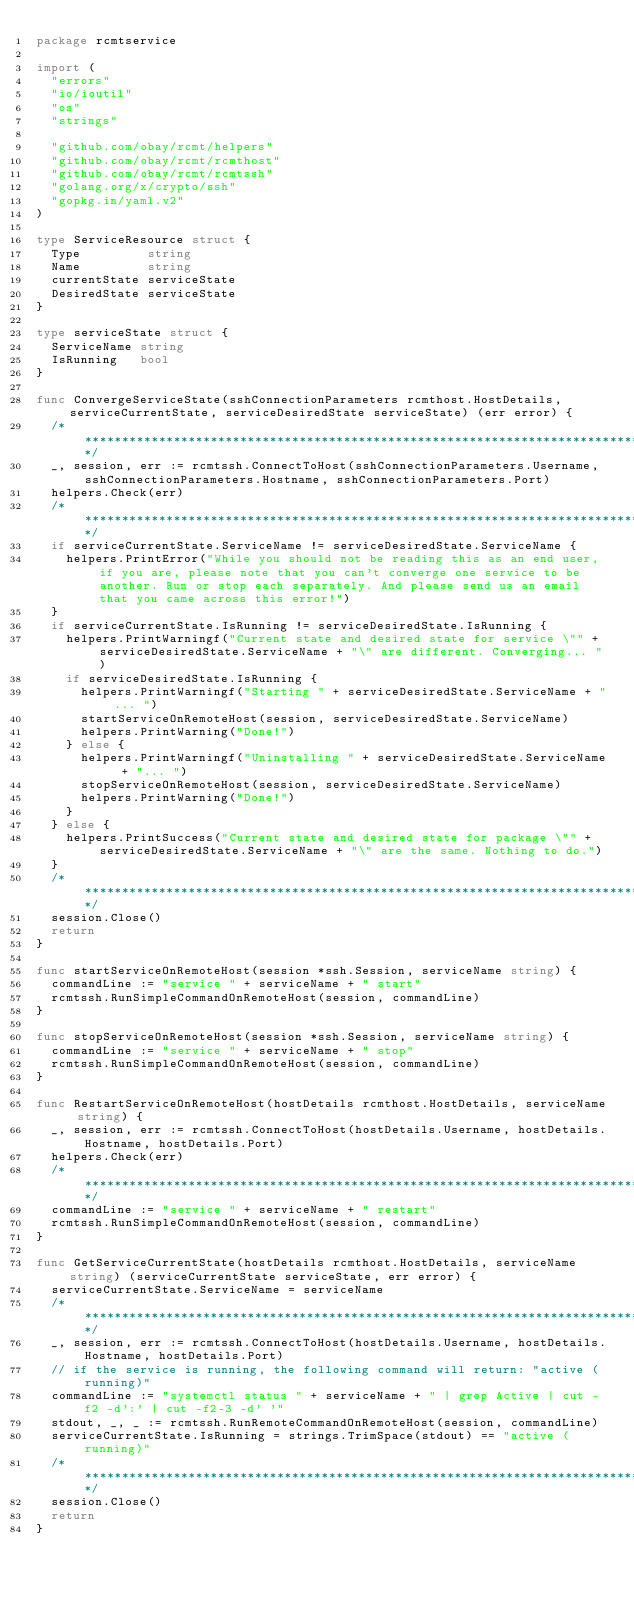<code> <loc_0><loc_0><loc_500><loc_500><_Go_>package rcmtservice

import (
	"errors"
	"io/ioutil"
	"os"
	"strings"

	"github.com/obay/rcmt/helpers"
	"github.com/obay/rcmt/rcmthost"
	"github.com/obay/rcmt/rcmtssh"
	"golang.org/x/crypto/ssh"
	"gopkg.in/yaml.v2"
)

type ServiceResource struct {
	Type         string
	Name         string
	currentState serviceState
	DesiredState serviceState
}

type serviceState struct {
	ServiceName string
	IsRunning   bool
}

func ConvergeServiceState(sshConnectionParameters rcmthost.HostDetails, serviceCurrentState, serviceDesiredState serviceState) (err error) {
	/*********************************************************************************************/
	_, session, err := rcmtssh.ConnectToHost(sshConnectionParameters.Username, sshConnectionParameters.Hostname, sshConnectionParameters.Port)
	helpers.Check(err)
	/*********************************************************************************************/
	if serviceCurrentState.ServiceName != serviceDesiredState.ServiceName {
		helpers.PrintError("While you should not be reading this as an end user, if you are, please note that you can't converge one service to be another. Run or stop each separately. And please send us an email that you came across this error!")
	}
	if serviceCurrentState.IsRunning != serviceDesiredState.IsRunning {
		helpers.PrintWarningf("Current state and desired state for service \"" + serviceDesiredState.ServiceName + "\" are different. Converging... ")
		if serviceDesiredState.IsRunning {
			helpers.PrintWarningf("Starting " + serviceDesiredState.ServiceName + "... ")
			startServiceOnRemoteHost(session, serviceDesiredState.ServiceName)
			helpers.PrintWarning("Done!")
		} else {
			helpers.PrintWarningf("Uninstalling " + serviceDesiredState.ServiceName + "... ")
			stopServiceOnRemoteHost(session, serviceDesiredState.ServiceName)
			helpers.PrintWarning("Done!")
		}
	} else {
		helpers.PrintSuccess("Current state and desired state for package \"" + serviceDesiredState.ServiceName + "\" are the same. Nothing to do.")
	}
	/*********************************************************************************************/
	session.Close()
	return
}

func startServiceOnRemoteHost(session *ssh.Session, serviceName string) {
	commandLine := "service " + serviceName + " start"
	rcmtssh.RunSimpleCommandOnRemoteHost(session, commandLine)
}

func stopServiceOnRemoteHost(session *ssh.Session, serviceName string) {
	commandLine := "service " + serviceName + " stop"
	rcmtssh.RunSimpleCommandOnRemoteHost(session, commandLine)
}

func RestartServiceOnRemoteHost(hostDetails rcmthost.HostDetails, serviceName string) {
	_, session, err := rcmtssh.ConnectToHost(hostDetails.Username, hostDetails.Hostname, hostDetails.Port)
	helpers.Check(err)
	/*********************************************************************************************/
	commandLine := "service " + serviceName + " restart"
	rcmtssh.RunSimpleCommandOnRemoteHost(session, commandLine)
}

func GetServiceCurrentState(hostDetails rcmthost.HostDetails, serviceName string) (serviceCurrentState serviceState, err error) {
	serviceCurrentState.ServiceName = serviceName
	/***********************************************************************************/
	_, session, err := rcmtssh.ConnectToHost(hostDetails.Username, hostDetails.Hostname, hostDetails.Port)
	// if the service is running, the following command will return: "active (running)"
	commandLine := "systemctl status " + serviceName + " | grep Active | cut -f2 -d':' | cut -f2-3 -d' '"
	stdout, _, _ := rcmtssh.RunRemoteCommandOnRemoteHost(session, commandLine)
	serviceCurrentState.IsRunning = strings.TrimSpace(stdout) == "active (running)"
	/***********************************************************************************/
	session.Close()
	return
}
</code> 